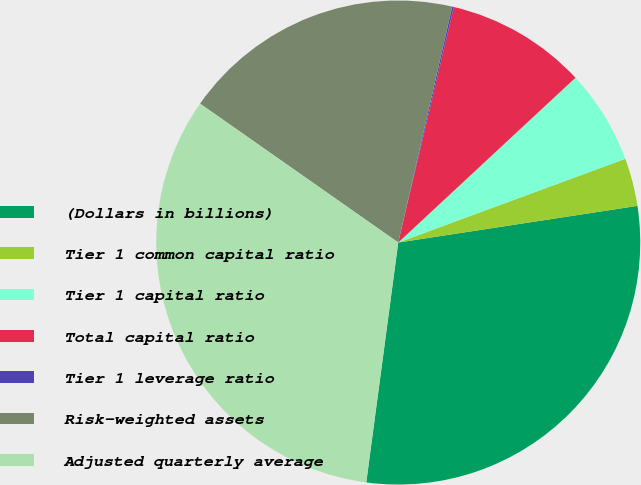<chart> <loc_0><loc_0><loc_500><loc_500><pie_chart><fcel>(Dollars in billions)<fcel>Tier 1 common capital ratio<fcel>Tier 1 capital ratio<fcel>Total capital ratio<fcel>Tier 1 leverage ratio<fcel>Risk-weighted assets<fcel>Adjusted quarterly average<nl><fcel>29.53%<fcel>3.2%<fcel>6.3%<fcel>9.39%<fcel>0.11%<fcel>18.85%<fcel>32.62%<nl></chart> 